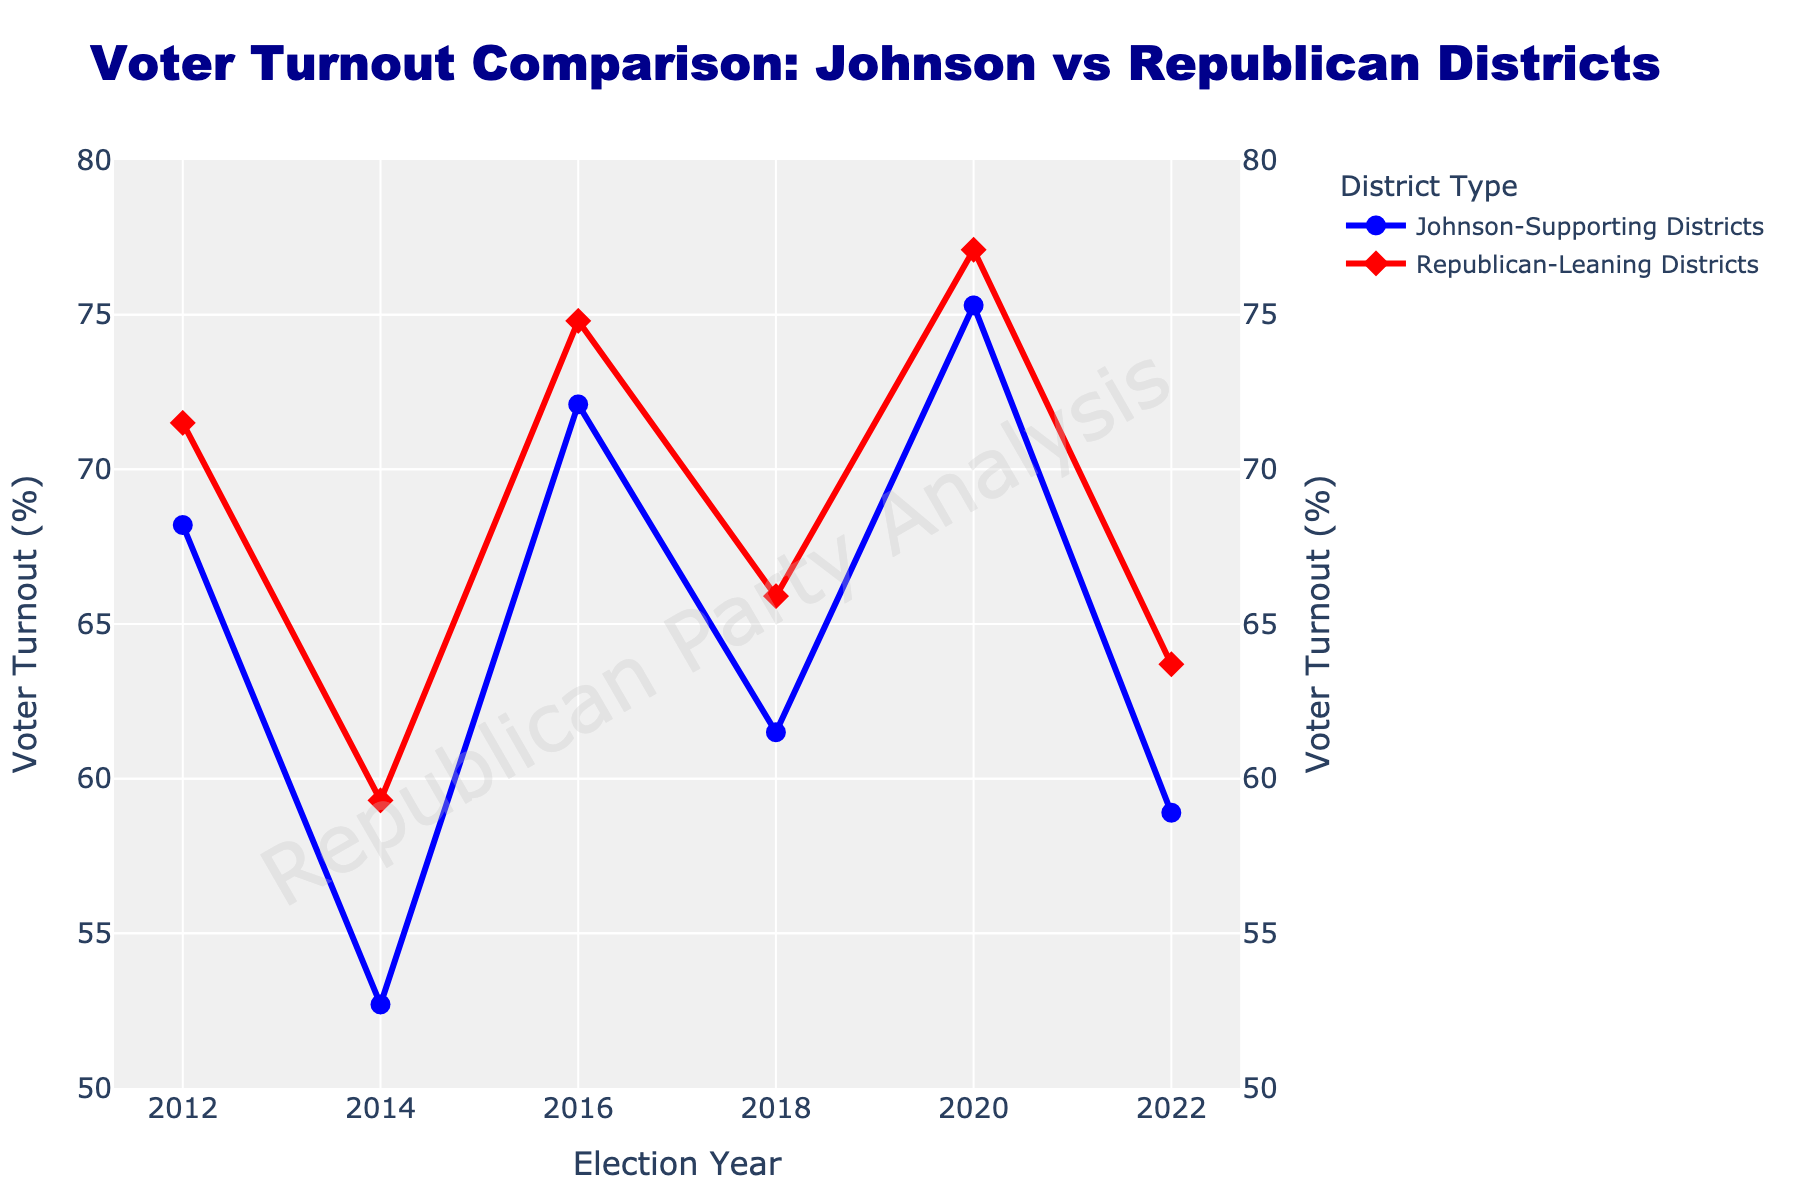What is the difference in voter turnout between Johnson-Supporting Districts and Republican-Leaning Districts in 2020? In the figure, the voter turnout for Johnson-Supporting Districts in 2020 is 75.3%, while for Republican-Leaning Districts it is 77.1%. Subtracting the two gives a difference of 77.1% - 75.3% = 1.8%.
Answer: 1.8% Which district type had higher voter turnout in the 2016 election? In the figure, the voter turnout for Johnson-Supporting Districts in 2016 is 72.1%, while for Republican-Leaning Districts it is 74.8%. Republican-Leaning Districts had higher voter turnout.
Answer: Republican-Leaning Districts What is the average voter turnout for Republican-Leaning Districts across all the years? The figure shows voter turnout in Republican-Leaning Districts for six years: 71.5%, 59.3%, 74.8%, 65.9%, 77.1%, and 63.7%. Summing these values: 71.5 + 59.3 + 74.8 + 65.9 + 77.1 + 63.7 = 412.3. Dividing by six gives 412.3 / 6 ≈ 68.72%.
Answer: 68.72% Between 2014 and 2016, which district type showed a bigger increase in voter turnout? From the figure, voter turnout in Johnson-Supporting Districts increased from 52.7% in 2014 to 72.1% in 2016, an increase of 72.1% - 52.7% = 19.4%. In Republican-Leaning Districts, it increased from 59.3% to 74.8%, an increase of 74.8% - 59.3% = 15.5%. Johnson-Supporting Districts showed a bigger increase.
Answer: Johnson-Supporting Districts How did the voter turnout trend for Johnson-Supporting Districts change from 2012 to 2022? Observing the line for Johnson-Supporting Districts, we see the following sequence of voter turnouts: 68.2% (2012), 52.7% (2014), 72.1% (2016), 61.5% (2018), 75.3% (2020), and 58.9% (2022). The trend shows a decreasing turnout from 2012 to 2014, a significant rise in 2016, a drop again in 2018, a peak in 2020, and another drop in 2022.
Answer: Fluctuating trend In which election year did both district types reach their highest voter turnout? The figure shows the highest voter turnout for both Johnson-Supporting (75.3%) and Republican-Leaning Districts (77.1%) is in the year 2020.
Answer: 2020 What is the total voter turnout in the year 2018 for both district types combined? According to the figure, voter turnout in 2018 for Johnson-Supporting Districts is 61.5% and for Republican-Leaning Districts is 65.9%. Adding these gives 61.5% + 65.9% = 127.4%.
Answer: 127.4% Which year had the smallest difference in voter turnout between the two district types? From the figure, we can calculate the differences for each year: 2012: 71.5% - 68.2% = 3.3%, 2014: 59.3% - 52.7% = 6.6%, 2016: 74.8% - 72.1% = 2.7%, 2018: 65.9% - 61.5% = 4.4%, 2020: 77.1% - 75.3% = 1.8%, 2022: 63.7% - 58.9% = 4.8%. The smallest difference is in the year 2020.
Answer: 2020 How many times did the Johnson-Supporting Districts have a voter turnout below 60%? According to the figure, voter turnout in Johnson-Supporting Districts was below 60% in the years 2014 (52.7%) and 2022 (58.9%). This happened 2 times.
Answer: 2 times 